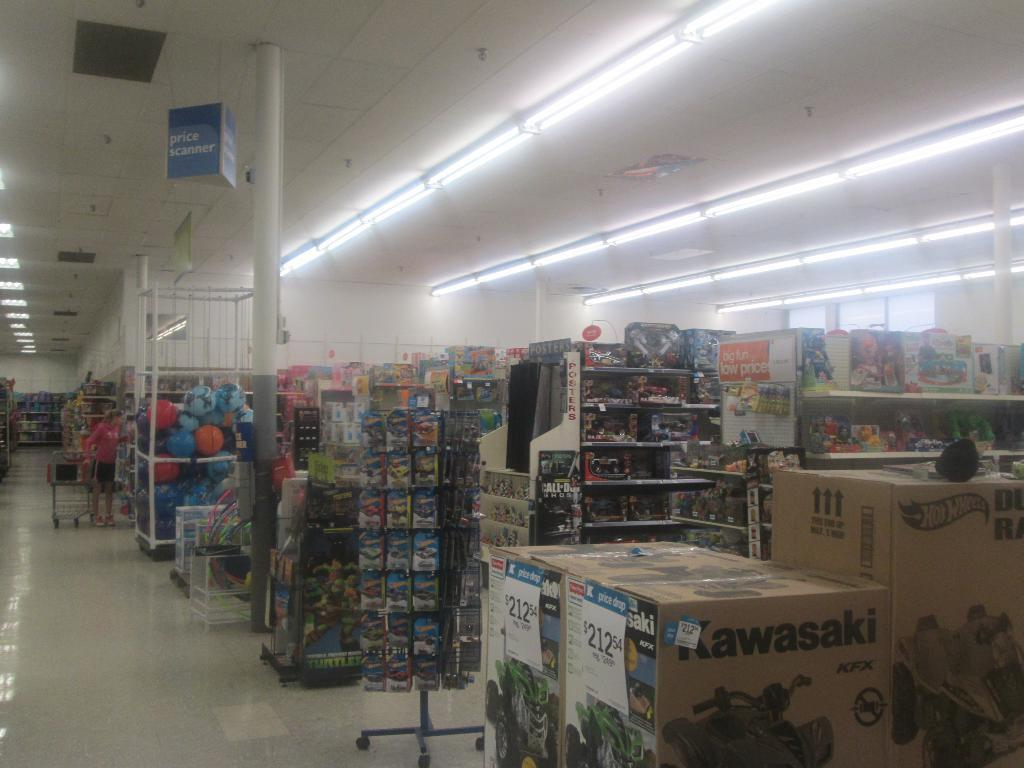<image>
Render a clear and concise summary of the photo. A store with lots of toy and a Kawasaki car toy. 